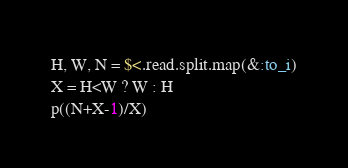Convert code to text. <code><loc_0><loc_0><loc_500><loc_500><_Ruby_>H, W, N = $<.read.split.map(&:to_i)
X = H<W ? W : H
p((N+X-1)/X)
</code> 